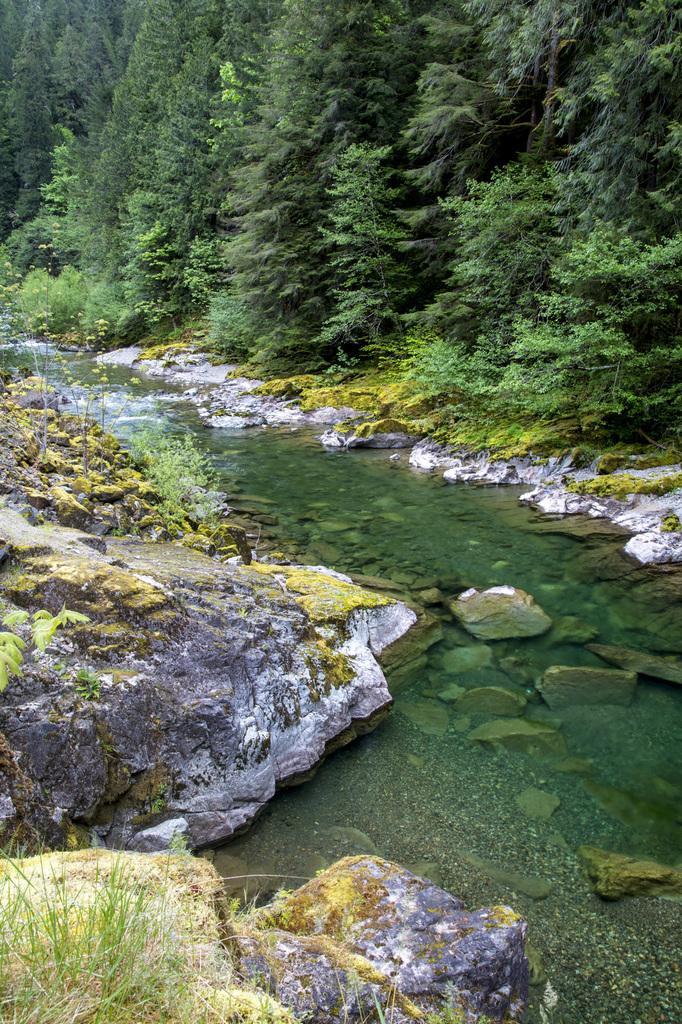How would you summarize this image in a sentence or two? In the center of the image there is water. On both right and left side of the image there are rocks. In the background of the image there are trees. 